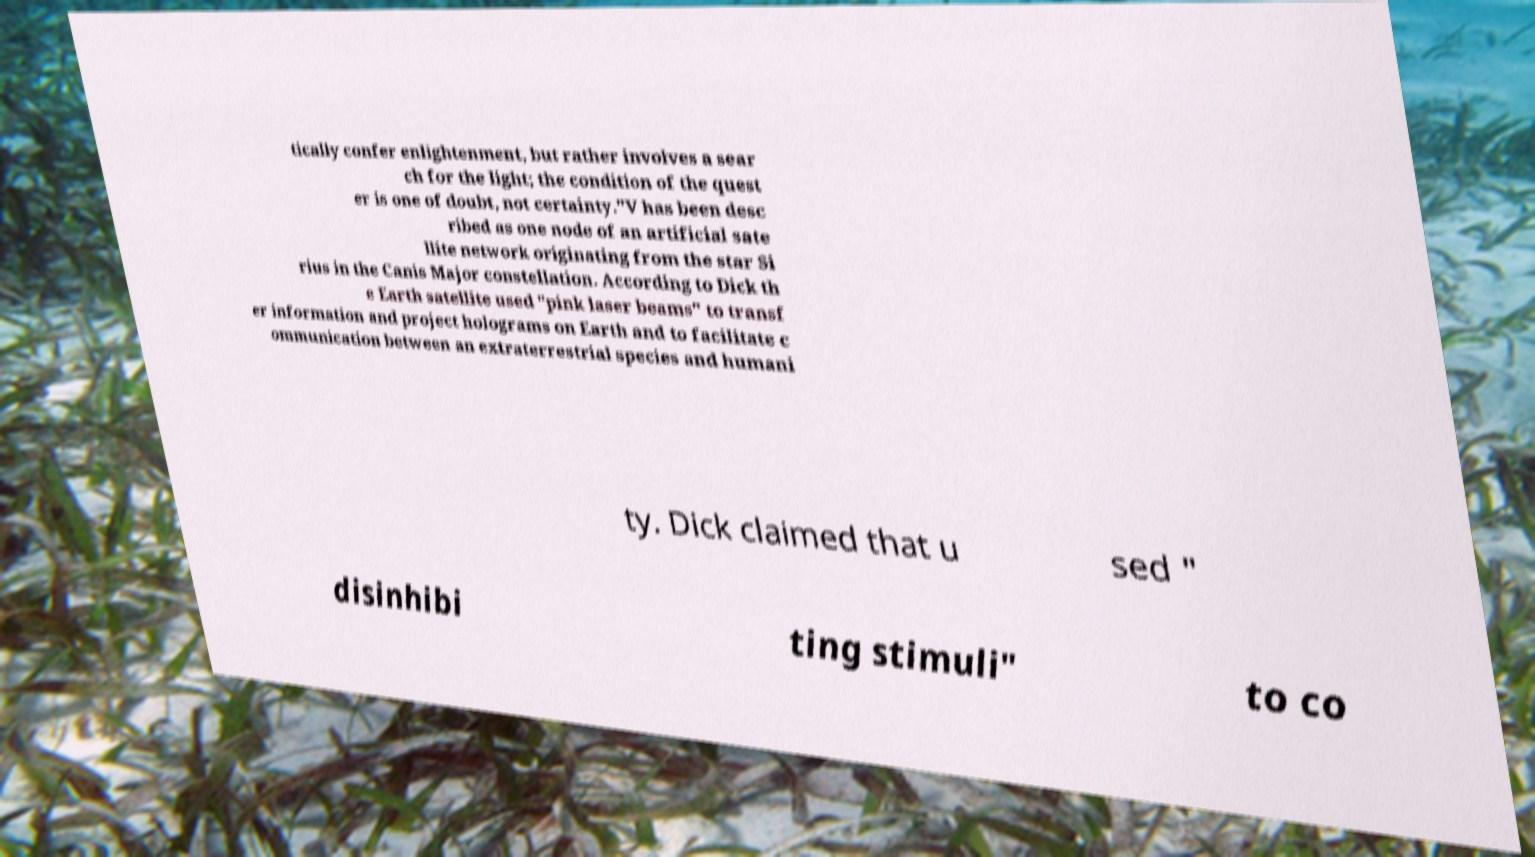Please identify and transcribe the text found in this image. tically confer enlightenment, but rather involves a sear ch for the light; the condition of the quest er is one of doubt, not certainty."V has been desc ribed as one node of an artificial sate llite network originating from the star Si rius in the Canis Major constellation. According to Dick th e Earth satellite used "pink laser beams" to transf er information and project holograms on Earth and to facilitate c ommunication between an extraterrestrial species and humani ty. Dick claimed that u sed " disinhibi ting stimuli" to co 